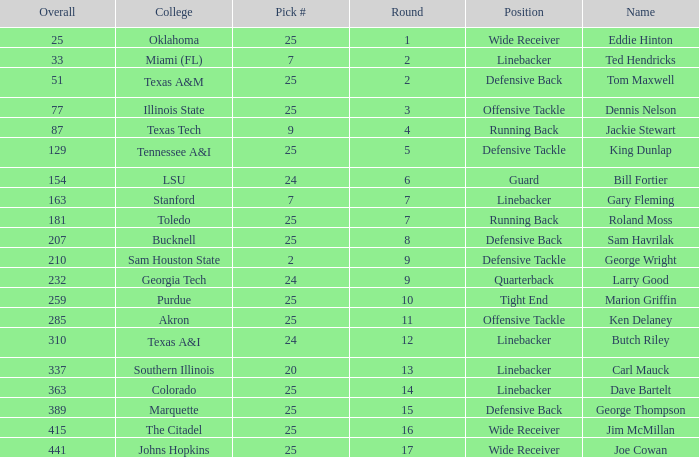College of lsu has how many rounds? 1.0. 